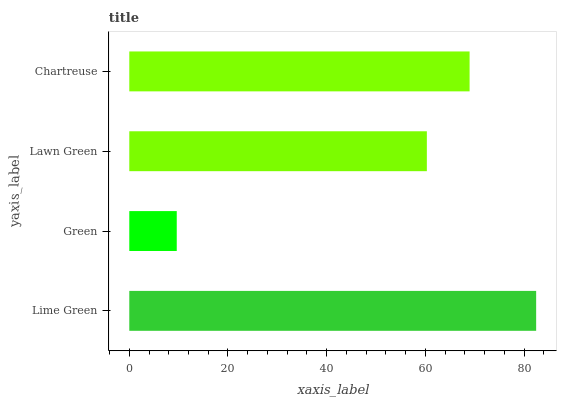Is Green the minimum?
Answer yes or no. Yes. Is Lime Green the maximum?
Answer yes or no. Yes. Is Lawn Green the minimum?
Answer yes or no. No. Is Lawn Green the maximum?
Answer yes or no. No. Is Lawn Green greater than Green?
Answer yes or no. Yes. Is Green less than Lawn Green?
Answer yes or no. Yes. Is Green greater than Lawn Green?
Answer yes or no. No. Is Lawn Green less than Green?
Answer yes or no. No. Is Chartreuse the high median?
Answer yes or no. Yes. Is Lawn Green the low median?
Answer yes or no. Yes. Is Green the high median?
Answer yes or no. No. Is Chartreuse the low median?
Answer yes or no. No. 